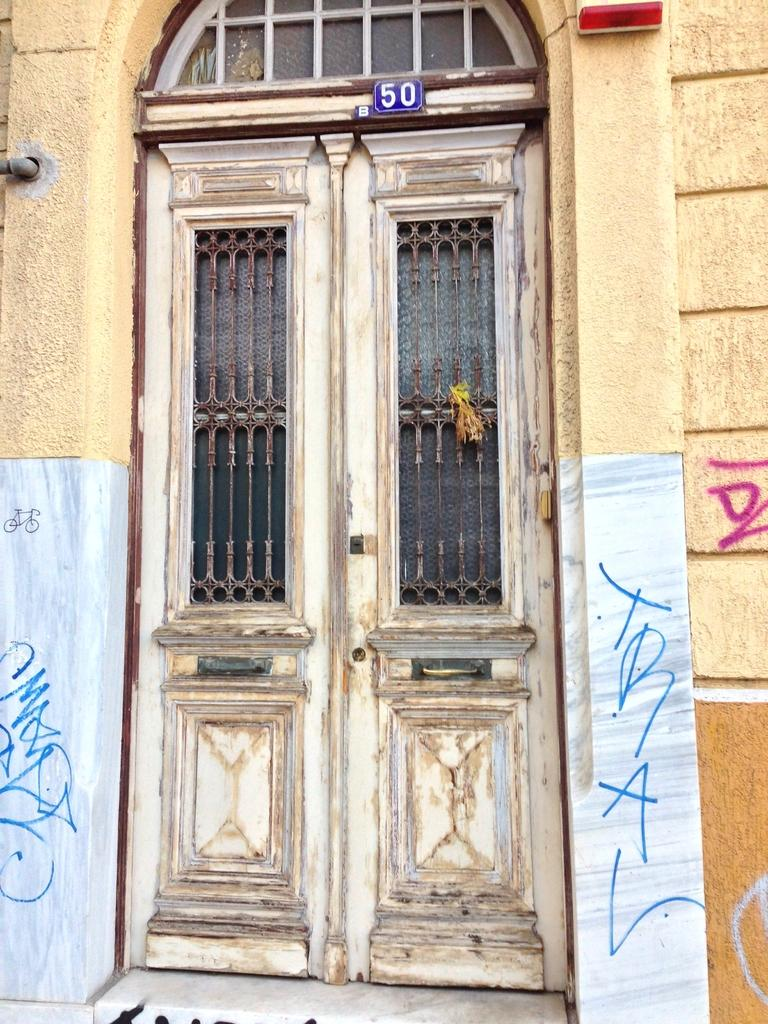What type of structure is present in the image? There is a building in the image. What features can be observed on the building? The building has windows and a door. Is there any additional information about the door? Yes, there is a blue color board attached to the door. Can you tell me how many animals are in the zoo depicted on the blue color board? There is no zoo depicted on the blue color board; it is simply a color board attached to the door. What type of degree is required to enter the building in the image? There is no mention of any degree requirement to enter the building in the image. 